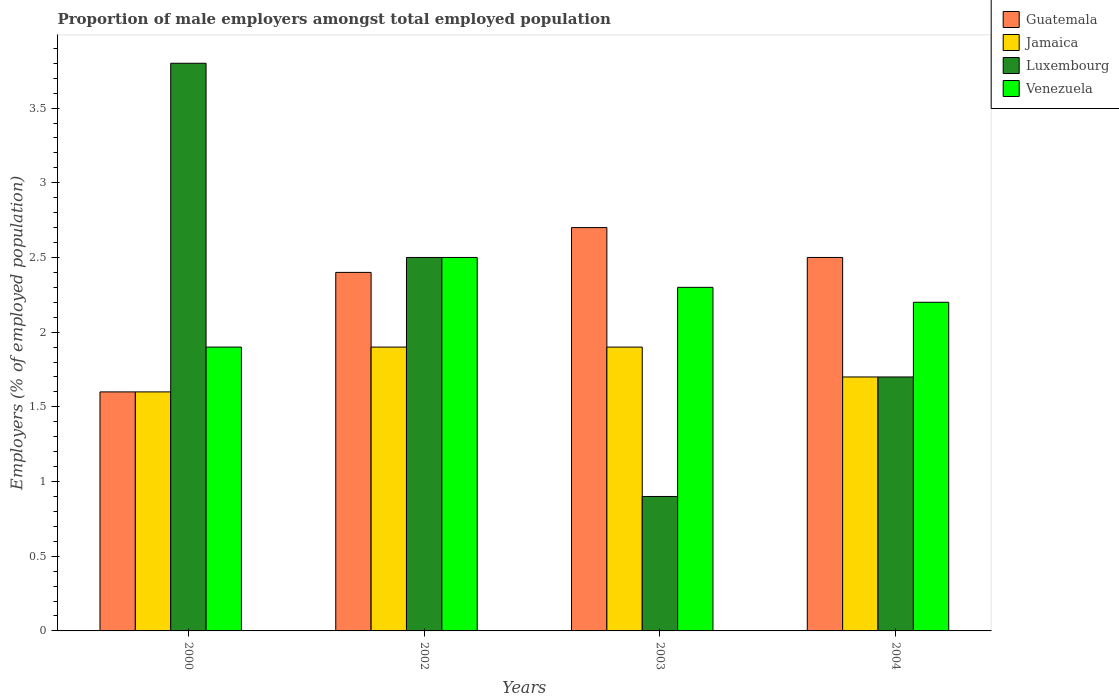How many different coloured bars are there?
Offer a very short reply. 4. How many groups of bars are there?
Your response must be concise. 4. What is the label of the 3rd group of bars from the left?
Your response must be concise. 2003. What is the proportion of male employers in Venezuela in 2004?
Keep it short and to the point. 2.2. Across all years, what is the maximum proportion of male employers in Venezuela?
Provide a succinct answer. 2.5. Across all years, what is the minimum proportion of male employers in Venezuela?
Offer a terse response. 1.9. In which year was the proportion of male employers in Venezuela maximum?
Your response must be concise. 2002. In which year was the proportion of male employers in Jamaica minimum?
Provide a short and direct response. 2000. What is the total proportion of male employers in Venezuela in the graph?
Your response must be concise. 8.9. What is the difference between the proportion of male employers in Luxembourg in 2000 and that in 2002?
Offer a very short reply. 1.3. What is the difference between the proportion of male employers in Guatemala in 2000 and the proportion of male employers in Luxembourg in 2002?
Make the answer very short. -0.9. What is the average proportion of male employers in Jamaica per year?
Ensure brevity in your answer.  1.78. In the year 2000, what is the difference between the proportion of male employers in Luxembourg and proportion of male employers in Venezuela?
Give a very brief answer. 1.9. In how many years, is the proportion of male employers in Guatemala greater than 0.6 %?
Your answer should be very brief. 4. What is the ratio of the proportion of male employers in Luxembourg in 2002 to that in 2004?
Provide a succinct answer. 1.47. Is the proportion of male employers in Luxembourg in 2000 less than that in 2003?
Give a very brief answer. No. Is the difference between the proportion of male employers in Luxembourg in 2002 and 2003 greater than the difference between the proportion of male employers in Venezuela in 2002 and 2003?
Provide a short and direct response. Yes. What is the difference between the highest and the second highest proportion of male employers in Venezuela?
Keep it short and to the point. 0.2. What is the difference between the highest and the lowest proportion of male employers in Jamaica?
Your response must be concise. 0.3. In how many years, is the proportion of male employers in Jamaica greater than the average proportion of male employers in Jamaica taken over all years?
Your answer should be compact. 2. Is it the case that in every year, the sum of the proportion of male employers in Guatemala and proportion of male employers in Venezuela is greater than the sum of proportion of male employers in Jamaica and proportion of male employers in Luxembourg?
Make the answer very short. No. What does the 3rd bar from the left in 2002 represents?
Provide a succinct answer. Luxembourg. What does the 3rd bar from the right in 2003 represents?
Give a very brief answer. Jamaica. Are all the bars in the graph horizontal?
Give a very brief answer. No. How many years are there in the graph?
Offer a very short reply. 4. What is the difference between two consecutive major ticks on the Y-axis?
Your answer should be compact. 0.5. Are the values on the major ticks of Y-axis written in scientific E-notation?
Provide a succinct answer. No. Does the graph contain any zero values?
Offer a very short reply. No. Does the graph contain grids?
Make the answer very short. No. Where does the legend appear in the graph?
Offer a terse response. Top right. How many legend labels are there?
Your answer should be compact. 4. How are the legend labels stacked?
Keep it short and to the point. Vertical. What is the title of the graph?
Give a very brief answer. Proportion of male employers amongst total employed population. Does "Burundi" appear as one of the legend labels in the graph?
Make the answer very short. No. What is the label or title of the X-axis?
Give a very brief answer. Years. What is the label or title of the Y-axis?
Your response must be concise. Employers (% of employed population). What is the Employers (% of employed population) of Guatemala in 2000?
Your answer should be compact. 1.6. What is the Employers (% of employed population) in Jamaica in 2000?
Your response must be concise. 1.6. What is the Employers (% of employed population) of Luxembourg in 2000?
Provide a short and direct response. 3.8. What is the Employers (% of employed population) in Venezuela in 2000?
Keep it short and to the point. 1.9. What is the Employers (% of employed population) in Guatemala in 2002?
Your response must be concise. 2.4. What is the Employers (% of employed population) in Jamaica in 2002?
Your answer should be compact. 1.9. What is the Employers (% of employed population) of Venezuela in 2002?
Ensure brevity in your answer.  2.5. What is the Employers (% of employed population) of Guatemala in 2003?
Ensure brevity in your answer.  2.7. What is the Employers (% of employed population) of Jamaica in 2003?
Ensure brevity in your answer.  1.9. What is the Employers (% of employed population) in Luxembourg in 2003?
Your response must be concise. 0.9. What is the Employers (% of employed population) of Venezuela in 2003?
Ensure brevity in your answer.  2.3. What is the Employers (% of employed population) in Guatemala in 2004?
Keep it short and to the point. 2.5. What is the Employers (% of employed population) of Jamaica in 2004?
Offer a terse response. 1.7. What is the Employers (% of employed population) in Luxembourg in 2004?
Your answer should be very brief. 1.7. What is the Employers (% of employed population) in Venezuela in 2004?
Ensure brevity in your answer.  2.2. Across all years, what is the maximum Employers (% of employed population) in Guatemala?
Make the answer very short. 2.7. Across all years, what is the maximum Employers (% of employed population) in Jamaica?
Provide a succinct answer. 1.9. Across all years, what is the maximum Employers (% of employed population) in Luxembourg?
Give a very brief answer. 3.8. Across all years, what is the minimum Employers (% of employed population) of Guatemala?
Give a very brief answer. 1.6. Across all years, what is the minimum Employers (% of employed population) in Jamaica?
Your answer should be very brief. 1.6. Across all years, what is the minimum Employers (% of employed population) of Luxembourg?
Provide a succinct answer. 0.9. Across all years, what is the minimum Employers (% of employed population) in Venezuela?
Your answer should be very brief. 1.9. What is the total Employers (% of employed population) of Luxembourg in the graph?
Your response must be concise. 8.9. What is the difference between the Employers (% of employed population) of Guatemala in 2000 and that in 2002?
Your response must be concise. -0.8. What is the difference between the Employers (% of employed population) of Luxembourg in 2000 and that in 2002?
Your answer should be very brief. 1.3. What is the difference between the Employers (% of employed population) in Venezuela in 2000 and that in 2002?
Make the answer very short. -0.6. What is the difference between the Employers (% of employed population) of Guatemala in 2000 and that in 2003?
Your answer should be compact. -1.1. What is the difference between the Employers (% of employed population) in Jamaica in 2000 and that in 2003?
Give a very brief answer. -0.3. What is the difference between the Employers (% of employed population) of Luxembourg in 2000 and that in 2004?
Provide a succinct answer. 2.1. What is the difference between the Employers (% of employed population) in Guatemala in 2002 and that in 2003?
Offer a terse response. -0.3. What is the difference between the Employers (% of employed population) in Jamaica in 2002 and that in 2003?
Offer a terse response. 0. What is the difference between the Employers (% of employed population) in Luxembourg in 2002 and that in 2003?
Make the answer very short. 1.6. What is the difference between the Employers (% of employed population) in Guatemala in 2003 and that in 2004?
Provide a short and direct response. 0.2. What is the difference between the Employers (% of employed population) in Jamaica in 2003 and that in 2004?
Your response must be concise. 0.2. What is the difference between the Employers (% of employed population) of Luxembourg in 2003 and that in 2004?
Your answer should be very brief. -0.8. What is the difference between the Employers (% of employed population) in Venezuela in 2003 and that in 2004?
Keep it short and to the point. 0.1. What is the difference between the Employers (% of employed population) of Guatemala in 2000 and the Employers (% of employed population) of Jamaica in 2002?
Ensure brevity in your answer.  -0.3. What is the difference between the Employers (% of employed population) of Guatemala in 2000 and the Employers (% of employed population) of Luxembourg in 2002?
Provide a succinct answer. -0.9. What is the difference between the Employers (% of employed population) of Guatemala in 2000 and the Employers (% of employed population) of Venezuela in 2002?
Your response must be concise. -0.9. What is the difference between the Employers (% of employed population) of Luxembourg in 2000 and the Employers (% of employed population) of Venezuela in 2002?
Give a very brief answer. 1.3. What is the difference between the Employers (% of employed population) of Jamaica in 2000 and the Employers (% of employed population) of Luxembourg in 2003?
Make the answer very short. 0.7. What is the difference between the Employers (% of employed population) of Guatemala in 2000 and the Employers (% of employed population) of Luxembourg in 2004?
Provide a succinct answer. -0.1. What is the difference between the Employers (% of employed population) of Guatemala in 2000 and the Employers (% of employed population) of Venezuela in 2004?
Offer a very short reply. -0.6. What is the difference between the Employers (% of employed population) in Jamaica in 2000 and the Employers (% of employed population) in Venezuela in 2004?
Offer a very short reply. -0.6. What is the difference between the Employers (% of employed population) in Guatemala in 2002 and the Employers (% of employed population) in Luxembourg in 2003?
Make the answer very short. 1.5. What is the difference between the Employers (% of employed population) in Guatemala in 2002 and the Employers (% of employed population) in Venezuela in 2003?
Your response must be concise. 0.1. What is the difference between the Employers (% of employed population) in Guatemala in 2002 and the Employers (% of employed population) in Jamaica in 2004?
Provide a succinct answer. 0.7. What is the difference between the Employers (% of employed population) of Guatemala in 2002 and the Employers (% of employed population) of Venezuela in 2004?
Your answer should be compact. 0.2. What is the difference between the Employers (% of employed population) in Jamaica in 2002 and the Employers (% of employed population) in Luxembourg in 2004?
Ensure brevity in your answer.  0.2. What is the difference between the Employers (% of employed population) in Guatemala in 2003 and the Employers (% of employed population) in Jamaica in 2004?
Keep it short and to the point. 1. What is the difference between the Employers (% of employed population) of Guatemala in 2003 and the Employers (% of employed population) of Luxembourg in 2004?
Make the answer very short. 1. What is the difference between the Employers (% of employed population) in Jamaica in 2003 and the Employers (% of employed population) in Venezuela in 2004?
Provide a succinct answer. -0.3. What is the difference between the Employers (% of employed population) in Luxembourg in 2003 and the Employers (% of employed population) in Venezuela in 2004?
Give a very brief answer. -1.3. What is the average Employers (% of employed population) in Jamaica per year?
Keep it short and to the point. 1.77. What is the average Employers (% of employed population) in Luxembourg per year?
Your response must be concise. 2.23. What is the average Employers (% of employed population) in Venezuela per year?
Provide a short and direct response. 2.23. In the year 2000, what is the difference between the Employers (% of employed population) in Guatemala and Employers (% of employed population) in Jamaica?
Give a very brief answer. 0. In the year 2000, what is the difference between the Employers (% of employed population) in Guatemala and Employers (% of employed population) in Luxembourg?
Your answer should be very brief. -2.2. In the year 2000, what is the difference between the Employers (% of employed population) in Guatemala and Employers (% of employed population) in Venezuela?
Your answer should be compact. -0.3. In the year 2000, what is the difference between the Employers (% of employed population) in Jamaica and Employers (% of employed population) in Luxembourg?
Ensure brevity in your answer.  -2.2. In the year 2000, what is the difference between the Employers (% of employed population) in Jamaica and Employers (% of employed population) in Venezuela?
Ensure brevity in your answer.  -0.3. In the year 2000, what is the difference between the Employers (% of employed population) in Luxembourg and Employers (% of employed population) in Venezuela?
Your answer should be compact. 1.9. In the year 2002, what is the difference between the Employers (% of employed population) in Jamaica and Employers (% of employed population) in Luxembourg?
Provide a short and direct response. -0.6. In the year 2003, what is the difference between the Employers (% of employed population) of Guatemala and Employers (% of employed population) of Jamaica?
Give a very brief answer. 0.8. In the year 2003, what is the difference between the Employers (% of employed population) of Guatemala and Employers (% of employed population) of Luxembourg?
Give a very brief answer. 1.8. In the year 2003, what is the difference between the Employers (% of employed population) of Guatemala and Employers (% of employed population) of Venezuela?
Provide a short and direct response. 0.4. In the year 2003, what is the difference between the Employers (% of employed population) in Luxembourg and Employers (% of employed population) in Venezuela?
Offer a very short reply. -1.4. In the year 2004, what is the difference between the Employers (% of employed population) in Guatemala and Employers (% of employed population) in Jamaica?
Offer a terse response. 0.8. In the year 2004, what is the difference between the Employers (% of employed population) in Guatemala and Employers (% of employed population) in Venezuela?
Provide a succinct answer. 0.3. In the year 2004, what is the difference between the Employers (% of employed population) in Jamaica and Employers (% of employed population) in Luxembourg?
Provide a short and direct response. 0. In the year 2004, what is the difference between the Employers (% of employed population) of Luxembourg and Employers (% of employed population) of Venezuela?
Offer a terse response. -0.5. What is the ratio of the Employers (% of employed population) in Jamaica in 2000 to that in 2002?
Your response must be concise. 0.84. What is the ratio of the Employers (% of employed population) of Luxembourg in 2000 to that in 2002?
Your response must be concise. 1.52. What is the ratio of the Employers (% of employed population) in Venezuela in 2000 to that in 2002?
Make the answer very short. 0.76. What is the ratio of the Employers (% of employed population) in Guatemala in 2000 to that in 2003?
Make the answer very short. 0.59. What is the ratio of the Employers (% of employed population) of Jamaica in 2000 to that in 2003?
Give a very brief answer. 0.84. What is the ratio of the Employers (% of employed population) in Luxembourg in 2000 to that in 2003?
Provide a succinct answer. 4.22. What is the ratio of the Employers (% of employed population) of Venezuela in 2000 to that in 2003?
Provide a short and direct response. 0.83. What is the ratio of the Employers (% of employed population) of Guatemala in 2000 to that in 2004?
Make the answer very short. 0.64. What is the ratio of the Employers (% of employed population) of Jamaica in 2000 to that in 2004?
Keep it short and to the point. 0.94. What is the ratio of the Employers (% of employed population) of Luxembourg in 2000 to that in 2004?
Make the answer very short. 2.24. What is the ratio of the Employers (% of employed population) of Venezuela in 2000 to that in 2004?
Give a very brief answer. 0.86. What is the ratio of the Employers (% of employed population) in Guatemala in 2002 to that in 2003?
Your answer should be compact. 0.89. What is the ratio of the Employers (% of employed population) in Luxembourg in 2002 to that in 2003?
Offer a very short reply. 2.78. What is the ratio of the Employers (% of employed population) of Venezuela in 2002 to that in 2003?
Provide a succinct answer. 1.09. What is the ratio of the Employers (% of employed population) of Guatemala in 2002 to that in 2004?
Provide a succinct answer. 0.96. What is the ratio of the Employers (% of employed population) of Jamaica in 2002 to that in 2004?
Offer a terse response. 1.12. What is the ratio of the Employers (% of employed population) of Luxembourg in 2002 to that in 2004?
Your answer should be very brief. 1.47. What is the ratio of the Employers (% of employed population) in Venezuela in 2002 to that in 2004?
Give a very brief answer. 1.14. What is the ratio of the Employers (% of employed population) in Jamaica in 2003 to that in 2004?
Give a very brief answer. 1.12. What is the ratio of the Employers (% of employed population) in Luxembourg in 2003 to that in 2004?
Ensure brevity in your answer.  0.53. What is the ratio of the Employers (% of employed population) in Venezuela in 2003 to that in 2004?
Provide a succinct answer. 1.05. What is the difference between the highest and the second highest Employers (% of employed population) in Guatemala?
Offer a terse response. 0.2. What is the difference between the highest and the second highest Employers (% of employed population) in Venezuela?
Make the answer very short. 0.2. What is the difference between the highest and the lowest Employers (% of employed population) of Guatemala?
Provide a short and direct response. 1.1. What is the difference between the highest and the lowest Employers (% of employed population) in Jamaica?
Offer a very short reply. 0.3. What is the difference between the highest and the lowest Employers (% of employed population) in Luxembourg?
Give a very brief answer. 2.9. What is the difference between the highest and the lowest Employers (% of employed population) in Venezuela?
Keep it short and to the point. 0.6. 